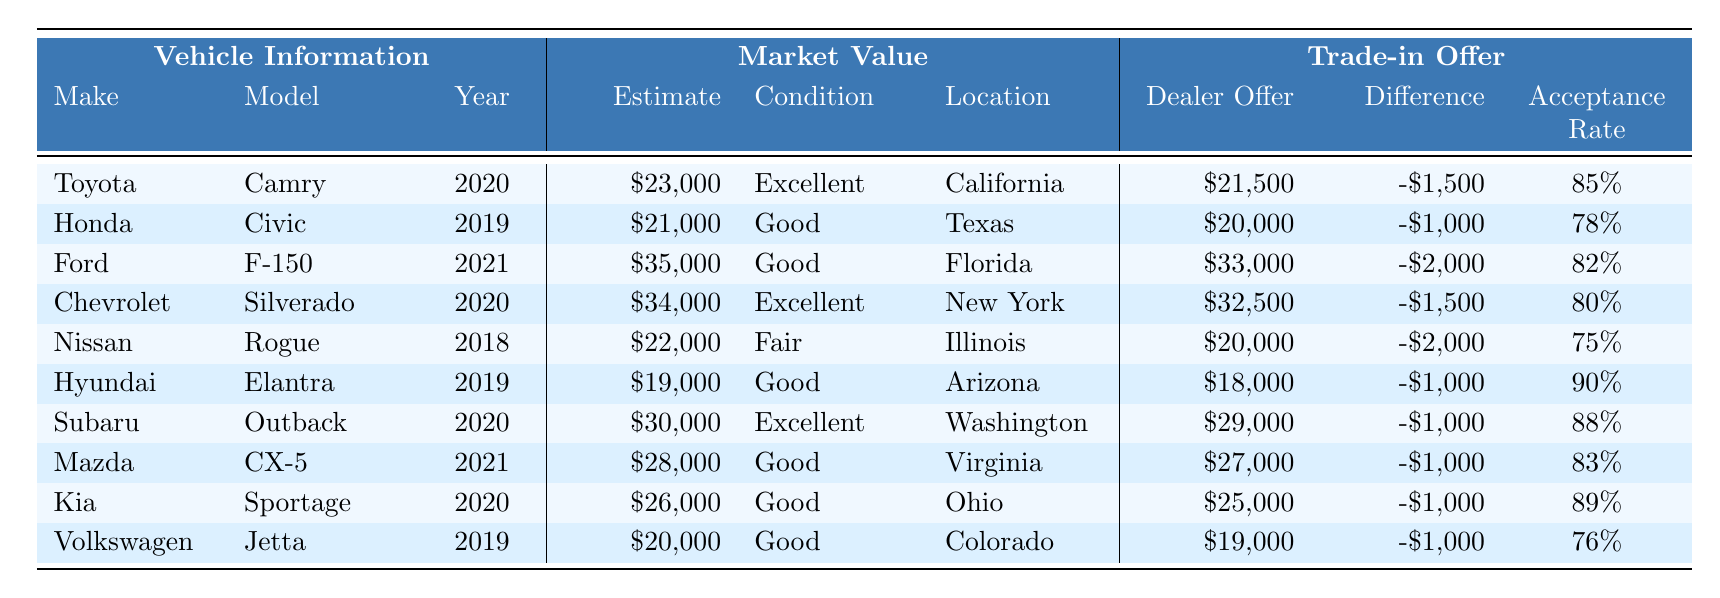What is the dealer offer for the Ford F-150? The table shows that the dealer offer for the Ford F-150 is listed under the "Trade-in Offer" section for that vehicle. The value is \$33,000.
Answer: \$33,000 How much lower is the dealer offer for the Hyundai Elantra compared to its market value estimate? The market value estimate for the Hyundai Elantra is \$19,000, and the dealer offer is \$18,000. To find how much lower the dealer offer is, subtract the dealer offer from the market value: \$19,000 - \$18,000 = \$1,000 lower.
Answer: \$1,000 Which vehicle has the highest acceptance rate? The acceptance rates are listed under the "Trade-in Offer" section. By comparing the rates for all vehicles, the highest acceptance rate is for the Hyundai Elantra, which is 90%.
Answer: 90% Is the trade-in offer for the Nissan Rogue higher or lower than the trade-in offer for the Toyota Camry? The trade-in offer for the Nissan Rogue is \$20,000 and for the Toyota Camry it is \$21,500. Since \$20,000 is less than \$21,500, the trade-in offer for the Nissan Rogue is lower.
Answer: Lower What is the average difference between the market value estimates and dealer offers for the vehicles? The differences are: -\$1,500 (Camry), -\$1,000 (Civic), -\$2,000 (F-150), -\$1,500 (Silverado), -\$2,000 (Rogue), -\$1,000 (Elantra), -\$1,000 (Outback), -\$1,000 (CX-5), -\$1,000 (Sportage), -\$1,000 (Jetta). Summing these gives -\$13,000, divided by 10 vehicles results in an average difference of -\$1,300.
Answer: -\$1,300 Which vehicle has the highest market value estimate and what is the difference from its trade-in offer? The highest market value estimate is for the Ford F-150 at \$35,000. The trade-in offer is \$33,000, so the difference is \$35,000 - \$33,000 = \$2,000.
Answer: \$2,000 How many vehicles have an acceptance rate above 80%? By examining the acceptance rates listed for each vehicle, the Toyota Camry (85%), Ford F-150 (82%), Hyundai Elantra (90%), Subaru Outback (88%), Mazda CX-5 (83%), and Kia Sportage (89%) are above 80%. This totals 6 vehicles.
Answer: 6 Is the dealer offer for the Volkswagen Jetta higher or lower than its market value estimate? The market value estimate for the Volkswagen Jetta is \$20,000 and the dealer offer is \$19,000. Since \$19,000 is less than \$20,000, the dealer offer is lower.
Answer: Lower 